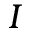<formula> <loc_0><loc_0><loc_500><loc_500>I</formula> 